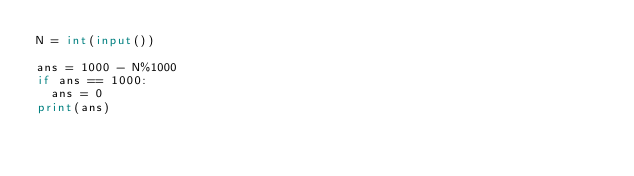Convert code to text. <code><loc_0><loc_0><loc_500><loc_500><_Python_>N = int(input())

ans = 1000 - N%1000
if ans == 1000:
  ans = 0
print(ans)</code> 